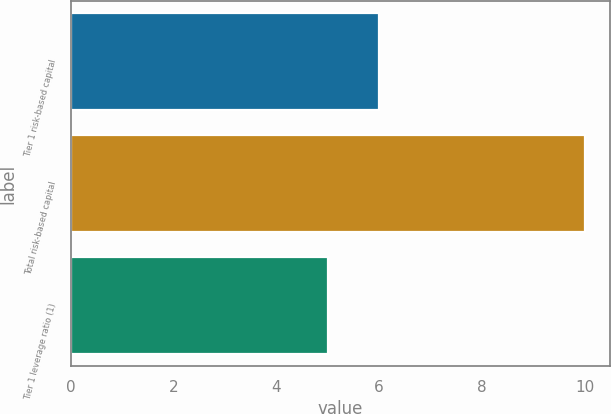Convert chart to OTSL. <chart><loc_0><loc_0><loc_500><loc_500><bar_chart><fcel>Tier 1 risk-based capital<fcel>Total risk-based capital<fcel>Tier 1 leverage ratio (1)<nl><fcel>6<fcel>10<fcel>5<nl></chart> 